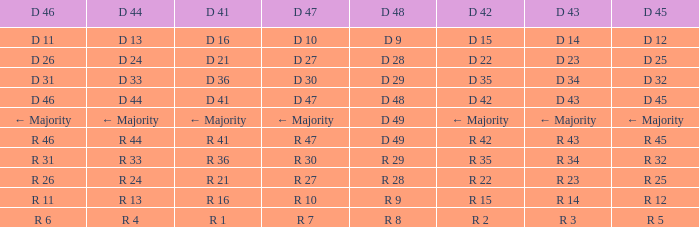Name the D 48 when it has a D 44 of d 33 D 29. 